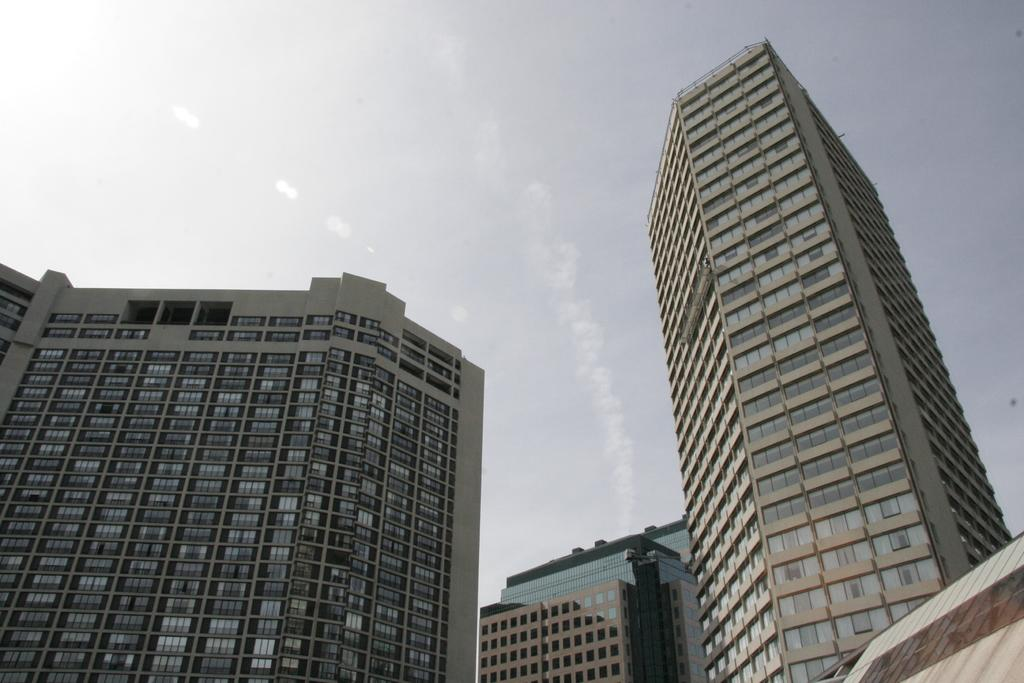What type of structures can be seen in the image? There are buildings in the image. What is visible at the top of the image? The sky is visible at the top of the image. What type of material is used for some parts of the buildings? There are glass structures on the buildings. What type of pocket can be seen on the sidewalk in the image? There is no pocket present on the sidewalk in the image. 